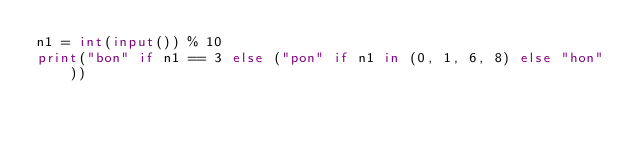Convert code to text. <code><loc_0><loc_0><loc_500><loc_500><_Python_>n1 = int(input()) % 10
print("bon" if n1 == 3 else ("pon" if n1 in (0, 1, 6, 8) else "hon"))</code> 